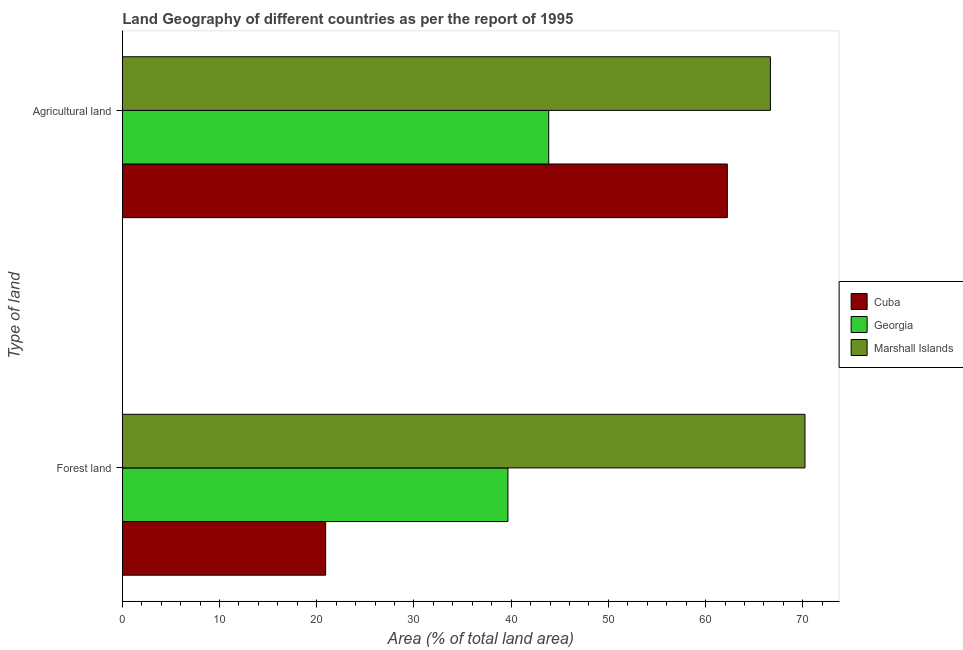How many different coloured bars are there?
Your response must be concise. 3. Are the number of bars per tick equal to the number of legend labels?
Ensure brevity in your answer.  Yes. Are the number of bars on each tick of the Y-axis equal?
Make the answer very short. Yes. How many bars are there on the 2nd tick from the bottom?
Your answer should be compact. 3. What is the label of the 1st group of bars from the top?
Offer a very short reply. Agricultural land. What is the percentage of land area under forests in Cuba?
Provide a short and direct response. 20.92. Across all countries, what is the maximum percentage of land area under agriculture?
Give a very brief answer. 66.67. Across all countries, what is the minimum percentage of land area under forests?
Your response must be concise. 20.92. In which country was the percentage of land area under agriculture maximum?
Offer a very short reply. Marshall Islands. In which country was the percentage of land area under forests minimum?
Keep it short and to the point. Cuba. What is the total percentage of land area under agriculture in the graph?
Keep it short and to the point. 172.76. What is the difference between the percentage of land area under forests in Marshall Islands and that in Cuba?
Provide a succinct answer. 49.31. What is the difference between the percentage of land area under forests in Cuba and the percentage of land area under agriculture in Marshall Islands?
Keep it short and to the point. -45.75. What is the average percentage of land area under forests per country?
Give a very brief answer. 43.6. What is the difference between the percentage of land area under forests and percentage of land area under agriculture in Marshall Islands?
Make the answer very short. 3.56. What is the ratio of the percentage of land area under forests in Cuba to that in Georgia?
Give a very brief answer. 0.53. In how many countries, is the percentage of land area under forests greater than the average percentage of land area under forests taken over all countries?
Your answer should be compact. 1. What does the 3rd bar from the top in Agricultural land represents?
Provide a short and direct response. Cuba. What does the 1st bar from the bottom in Forest land represents?
Offer a very short reply. Cuba. Are all the bars in the graph horizontal?
Your response must be concise. Yes. Are the values on the major ticks of X-axis written in scientific E-notation?
Provide a succinct answer. No. Does the graph contain any zero values?
Offer a terse response. No. Does the graph contain grids?
Provide a short and direct response. No. What is the title of the graph?
Your answer should be compact. Land Geography of different countries as per the report of 1995. Does "Netherlands" appear as one of the legend labels in the graph?
Your response must be concise. No. What is the label or title of the X-axis?
Your answer should be very brief. Area (% of total land area). What is the label or title of the Y-axis?
Your response must be concise. Type of land. What is the Area (% of total land area) in Cuba in Forest land?
Your response must be concise. 20.92. What is the Area (% of total land area) in Georgia in Forest land?
Your answer should be very brief. 39.67. What is the Area (% of total land area) of Marshall Islands in Forest land?
Your answer should be very brief. 70.22. What is the Area (% of total land area) in Cuba in Agricultural land?
Make the answer very short. 62.23. What is the Area (% of total land area) in Georgia in Agricultural land?
Keep it short and to the point. 43.86. What is the Area (% of total land area) in Marshall Islands in Agricultural land?
Keep it short and to the point. 66.67. Across all Type of land, what is the maximum Area (% of total land area) of Cuba?
Give a very brief answer. 62.23. Across all Type of land, what is the maximum Area (% of total land area) of Georgia?
Keep it short and to the point. 43.86. Across all Type of land, what is the maximum Area (% of total land area) in Marshall Islands?
Keep it short and to the point. 70.22. Across all Type of land, what is the minimum Area (% of total land area) of Cuba?
Your answer should be very brief. 20.92. Across all Type of land, what is the minimum Area (% of total land area) of Georgia?
Give a very brief answer. 39.67. Across all Type of land, what is the minimum Area (% of total land area) of Marshall Islands?
Your answer should be compact. 66.67. What is the total Area (% of total land area) in Cuba in the graph?
Your response must be concise. 83.15. What is the total Area (% of total land area) in Georgia in the graph?
Provide a short and direct response. 83.53. What is the total Area (% of total land area) in Marshall Islands in the graph?
Ensure brevity in your answer.  136.89. What is the difference between the Area (% of total land area) of Cuba in Forest land and that in Agricultural land?
Provide a short and direct response. -41.32. What is the difference between the Area (% of total land area) in Georgia in Forest land and that in Agricultural land?
Ensure brevity in your answer.  -4.2. What is the difference between the Area (% of total land area) in Marshall Islands in Forest land and that in Agricultural land?
Offer a terse response. 3.56. What is the difference between the Area (% of total land area) of Cuba in Forest land and the Area (% of total land area) of Georgia in Agricultural land?
Give a very brief answer. -22.95. What is the difference between the Area (% of total land area) of Cuba in Forest land and the Area (% of total land area) of Marshall Islands in Agricultural land?
Your answer should be very brief. -45.75. What is the difference between the Area (% of total land area) of Georgia in Forest land and the Area (% of total land area) of Marshall Islands in Agricultural land?
Your response must be concise. -27. What is the average Area (% of total land area) in Cuba per Type of land?
Give a very brief answer. 41.58. What is the average Area (% of total land area) of Georgia per Type of land?
Provide a succinct answer. 41.76. What is the average Area (% of total land area) of Marshall Islands per Type of land?
Give a very brief answer. 68.44. What is the difference between the Area (% of total land area) in Cuba and Area (% of total land area) in Georgia in Forest land?
Offer a terse response. -18.75. What is the difference between the Area (% of total land area) in Cuba and Area (% of total land area) in Marshall Islands in Forest land?
Make the answer very short. -49.31. What is the difference between the Area (% of total land area) in Georgia and Area (% of total land area) in Marshall Islands in Forest land?
Your answer should be very brief. -30.56. What is the difference between the Area (% of total land area) of Cuba and Area (% of total land area) of Georgia in Agricultural land?
Keep it short and to the point. 18.37. What is the difference between the Area (% of total land area) in Cuba and Area (% of total land area) in Marshall Islands in Agricultural land?
Your response must be concise. -4.43. What is the difference between the Area (% of total land area) in Georgia and Area (% of total land area) in Marshall Islands in Agricultural land?
Give a very brief answer. -22.8. What is the ratio of the Area (% of total land area) of Cuba in Forest land to that in Agricultural land?
Provide a short and direct response. 0.34. What is the ratio of the Area (% of total land area) of Georgia in Forest land to that in Agricultural land?
Your answer should be very brief. 0.9. What is the ratio of the Area (% of total land area) in Marshall Islands in Forest land to that in Agricultural land?
Offer a terse response. 1.05. What is the difference between the highest and the second highest Area (% of total land area) in Cuba?
Make the answer very short. 41.32. What is the difference between the highest and the second highest Area (% of total land area) of Georgia?
Make the answer very short. 4.2. What is the difference between the highest and the second highest Area (% of total land area) in Marshall Islands?
Make the answer very short. 3.56. What is the difference between the highest and the lowest Area (% of total land area) in Cuba?
Make the answer very short. 41.32. What is the difference between the highest and the lowest Area (% of total land area) of Georgia?
Offer a terse response. 4.2. What is the difference between the highest and the lowest Area (% of total land area) in Marshall Islands?
Provide a short and direct response. 3.56. 